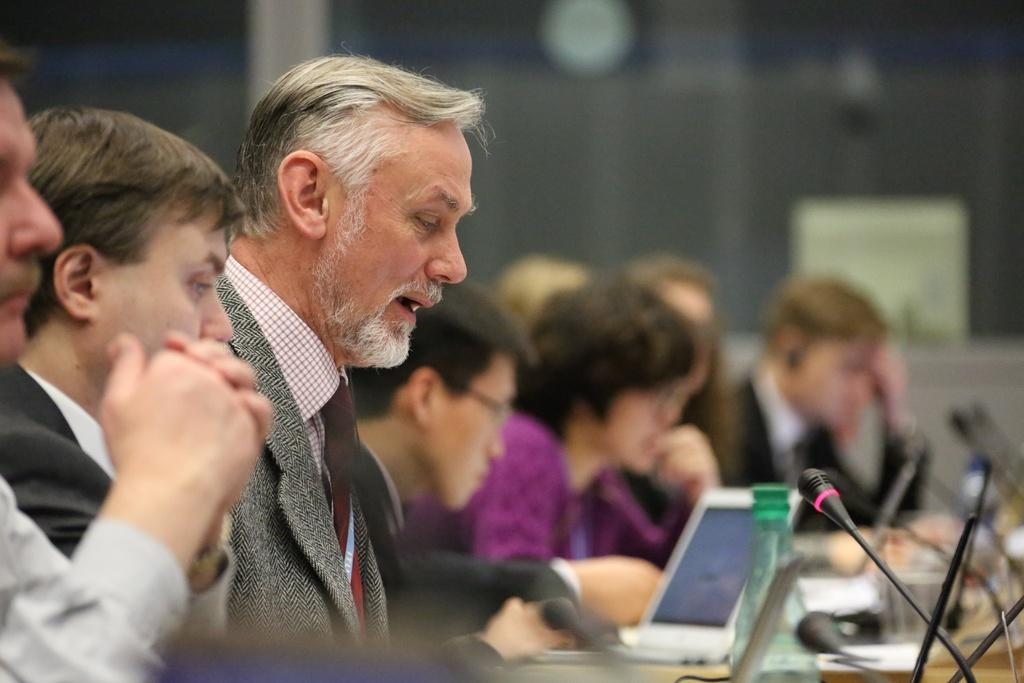How many people are in the image? There is a group of people in the image. What are the people in the image doing? The people are sitting in front of a table. What can be seen on the table in the image? There are microphones, a bottle, and other objects on the table. What is the man in the image wearing? The man is wearing a tie, suit, and shirt. What type of houses can be seen in the background of the image? There are no houses visible in the image; it only shows a group of people sitting at a table with microphones, a bottle, and other objects. What kind of wine is being served in the image? There is no wine present in the image; only a bottle is visible on the table, but its contents are not specified. 